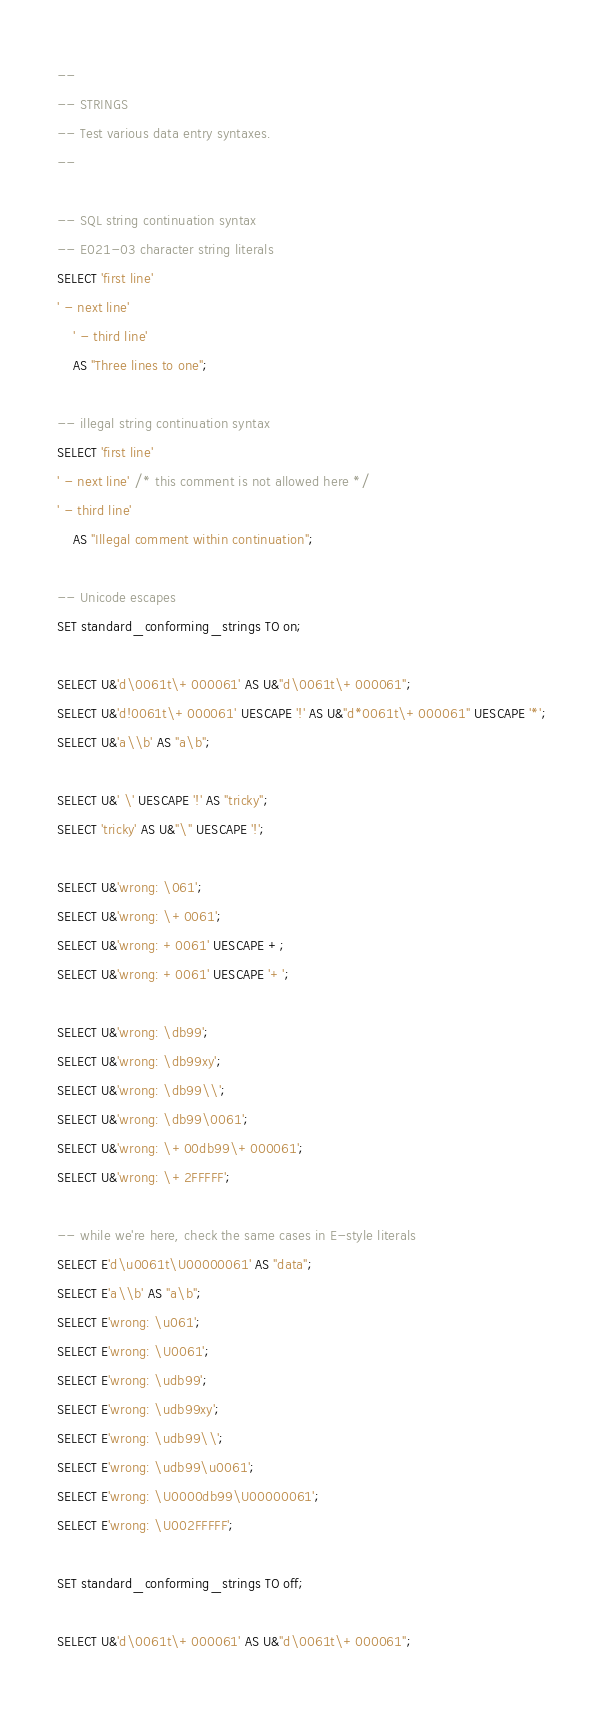<code> <loc_0><loc_0><loc_500><loc_500><_SQL_>--
-- STRINGS
-- Test various data entry syntaxes.
--

-- SQL string continuation syntax
-- E021-03 character string literals
SELECT 'first line'
' - next line'
	' - third line'
	AS "Three lines to one";

-- illegal string continuation syntax
SELECT 'first line'
' - next line' /* this comment is not allowed here */
' - third line'
	AS "Illegal comment within continuation";

-- Unicode escapes
SET standard_conforming_strings TO on;

SELECT U&'d\0061t\+000061' AS U&"d\0061t\+000061";
SELECT U&'d!0061t\+000061' UESCAPE '!' AS U&"d*0061t\+000061" UESCAPE '*';
SELECT U&'a\\b' AS "a\b";

SELECT U&' \' UESCAPE '!' AS "tricky";
SELECT 'tricky' AS U&"\" UESCAPE '!';

SELECT U&'wrong: \061';
SELECT U&'wrong: \+0061';
SELECT U&'wrong: +0061' UESCAPE +;
SELECT U&'wrong: +0061' UESCAPE '+';

SELECT U&'wrong: \db99';
SELECT U&'wrong: \db99xy';
SELECT U&'wrong: \db99\\';
SELECT U&'wrong: \db99\0061';
SELECT U&'wrong: \+00db99\+000061';
SELECT U&'wrong: \+2FFFFF';

-- while we're here, check the same cases in E-style literals
SELECT E'd\u0061t\U00000061' AS "data";
SELECT E'a\\b' AS "a\b";
SELECT E'wrong: \u061';
SELECT E'wrong: \U0061';
SELECT E'wrong: \udb99';
SELECT E'wrong: \udb99xy';
SELECT E'wrong: \udb99\\';
SELECT E'wrong: \udb99\u0061';
SELECT E'wrong: \U0000db99\U00000061';
SELECT E'wrong: \U002FFFFF';

SET standard_conforming_strings TO off;

SELECT U&'d\0061t\+000061' AS U&"d\0061t\+000061";</code> 